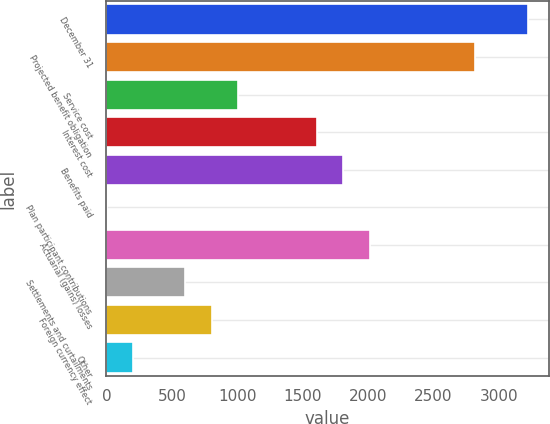<chart> <loc_0><loc_0><loc_500><loc_500><bar_chart><fcel>December 31<fcel>Projected benefit obligation<fcel>Service cost<fcel>Interest cost<fcel>Benefits paid<fcel>Plan participant contributions<fcel>Actuarial (gains) losses<fcel>Settlements and curtailments<fcel>Foreign currency effect<fcel>Other<nl><fcel>3220.5<fcel>2818<fcel>1006.75<fcel>1610.5<fcel>1811.75<fcel>0.5<fcel>2013<fcel>604.25<fcel>805.5<fcel>201.75<nl></chart> 